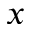Convert formula to latex. <formula><loc_0><loc_0><loc_500><loc_500>x</formula> 